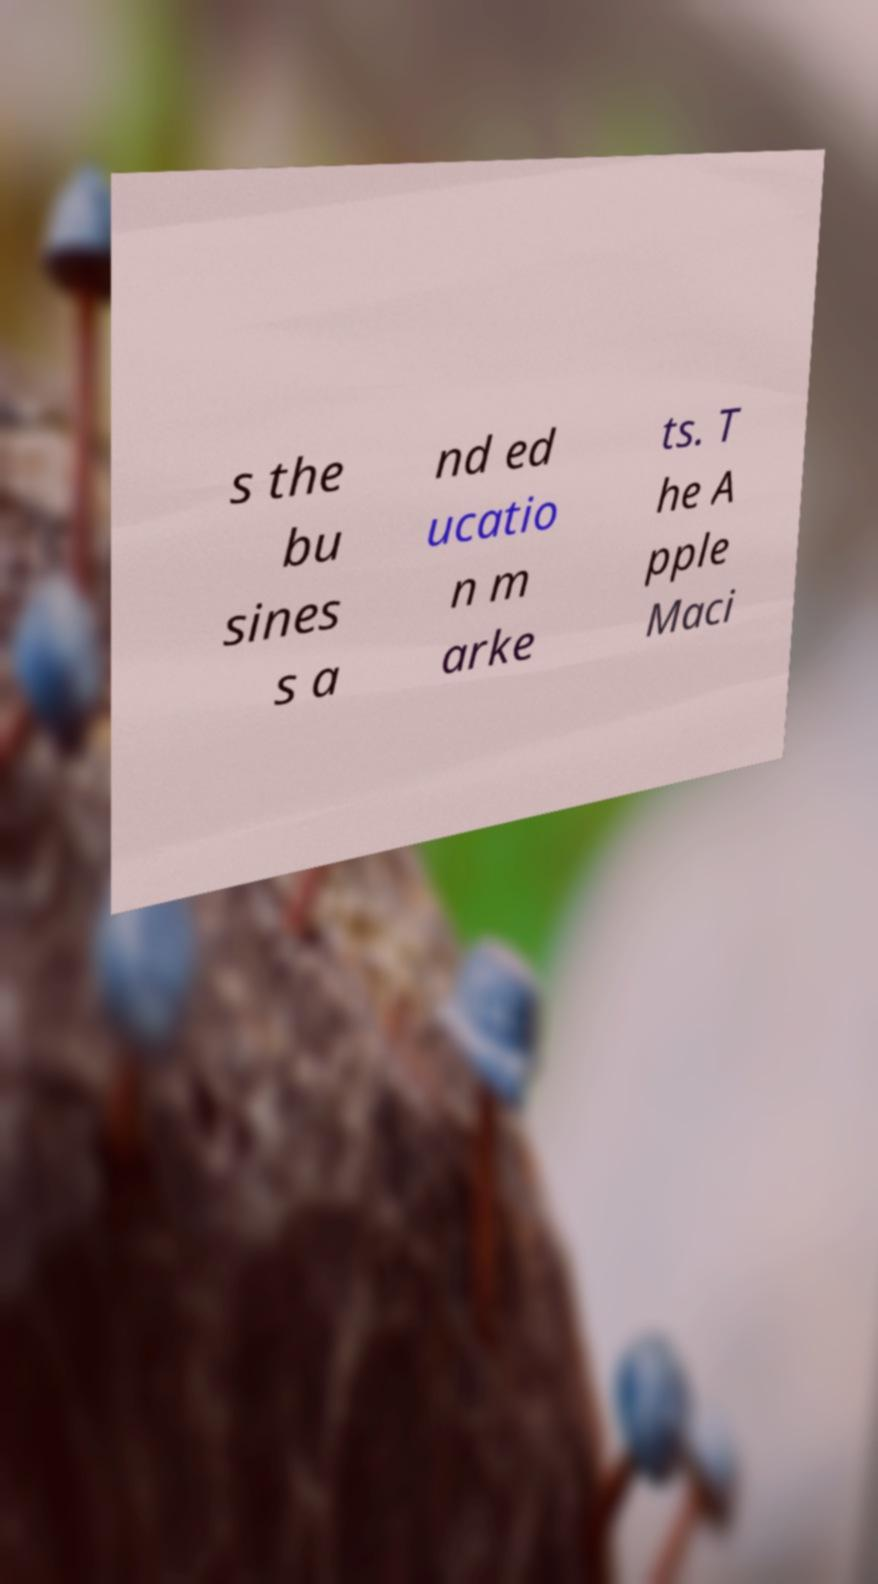Please identify and transcribe the text found in this image. s the bu sines s a nd ed ucatio n m arke ts. T he A pple Maci 